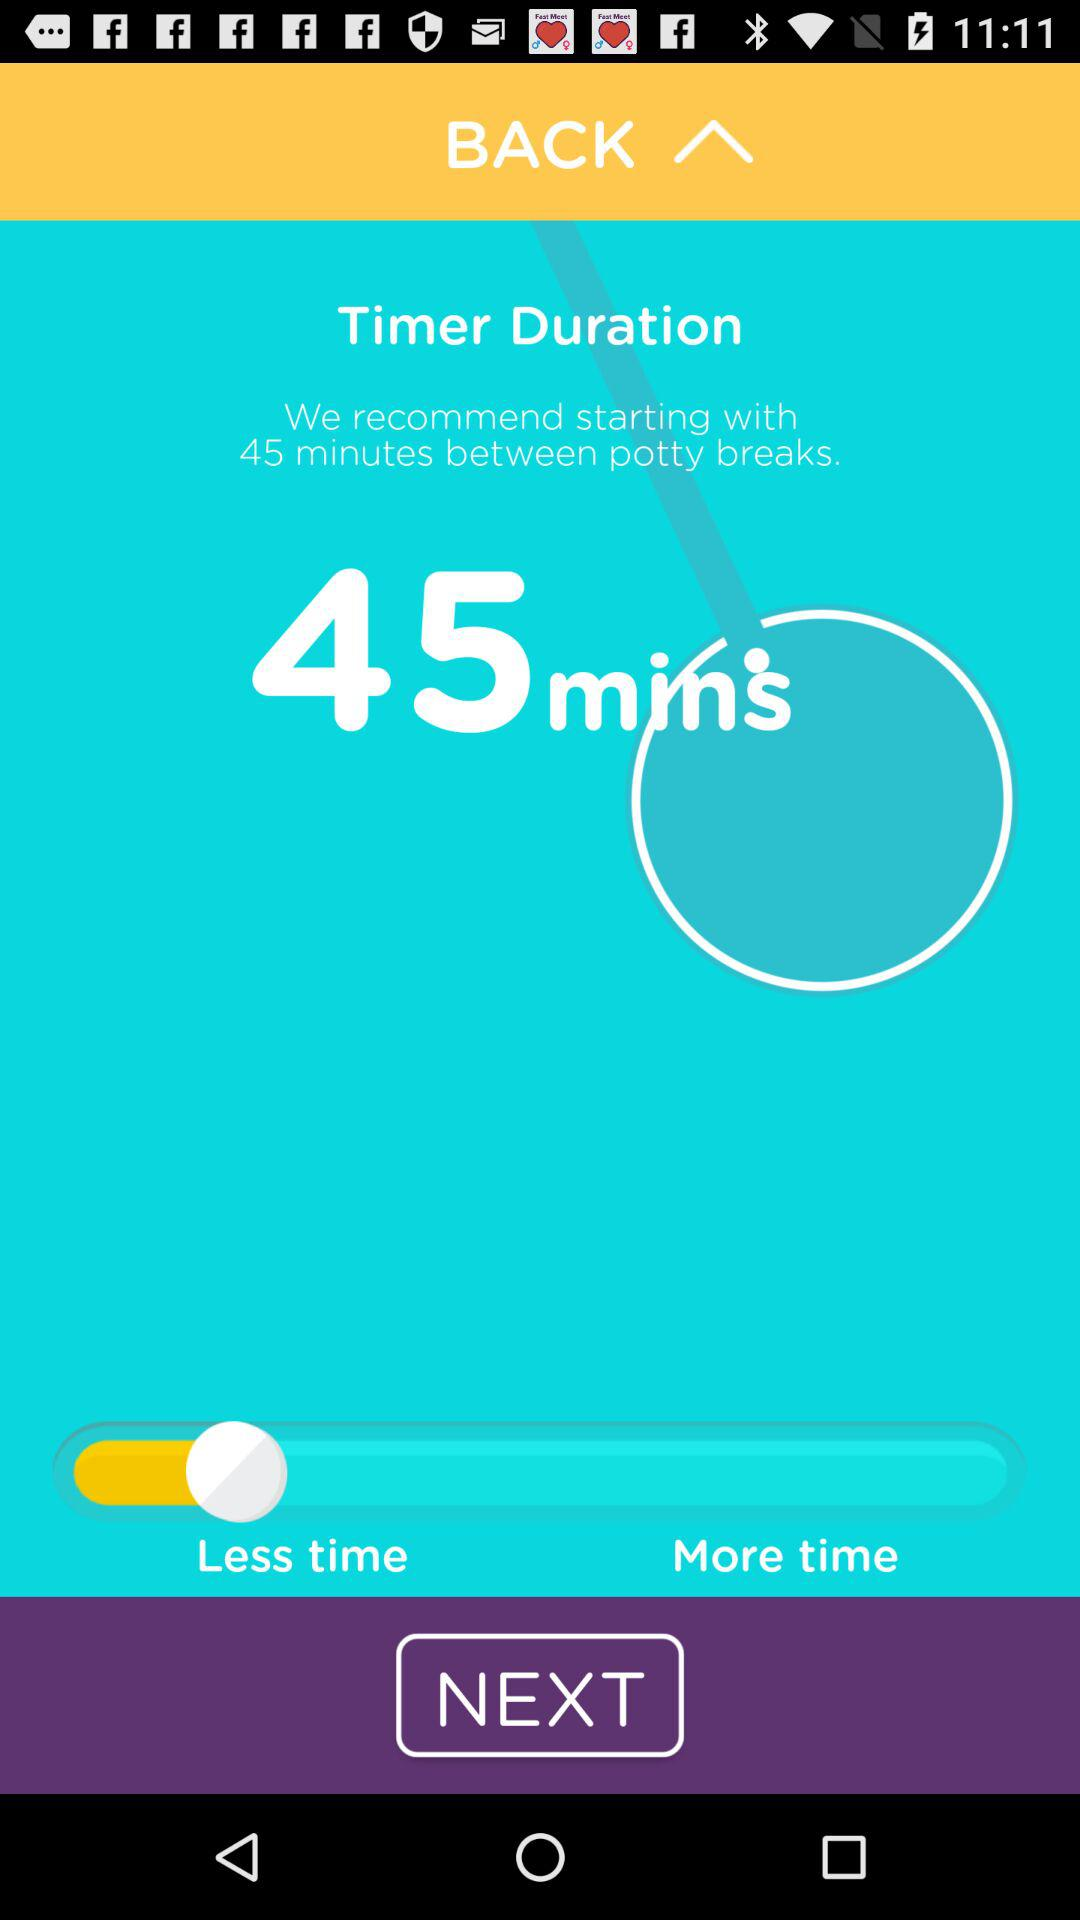What do you think could be improved in the design of this app's interface? The design could be improved by offering clearer labeling of the features and buttons. For instance, defining what 'Less time' and 'More time' specifically mean in minutes can enhance user understanding. Adding tooltips or a help button might also provide users with immediate guidance on how to use the app more effectively. 